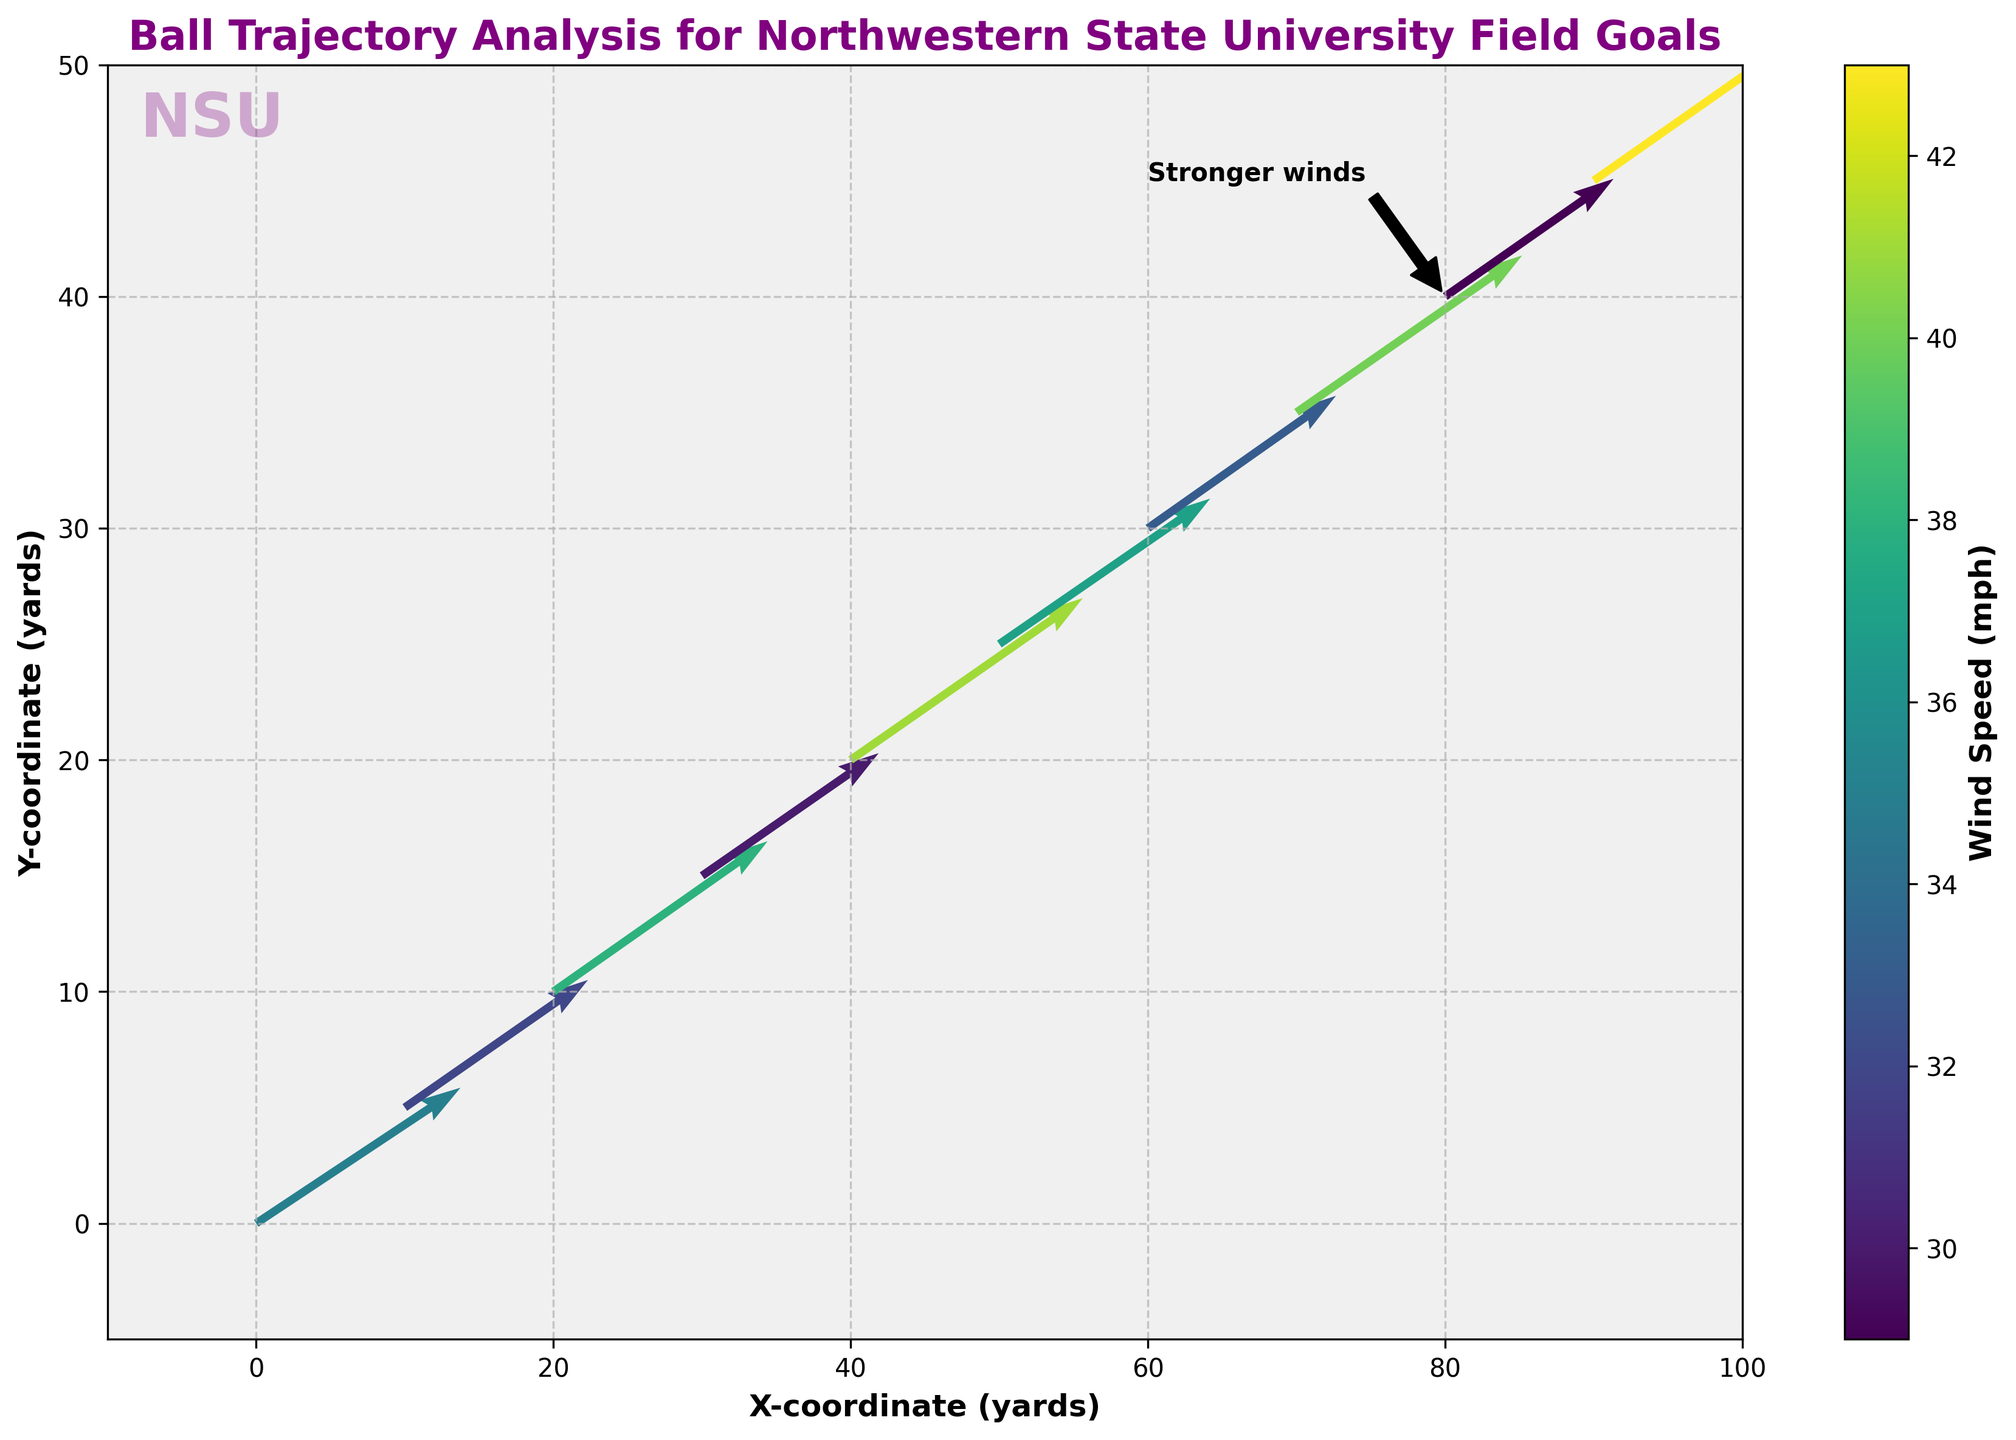What is the title of the figure? The title of the figure is displayed at the top and main text indicates what the plot is about.
Answer: Ball Trajectory Analysis for Northwestern State University Field Goals What does the color bar represent in this figure? The label on the color bar indicates what measure it represents, typically found on the vertical color gradient.
Answer: Wind Speed (mph) How many data points are depicted in the plot? Each arrow in the quiver plot represents a data point, and counting them gives the total number.
Answer: 10 What are the units for the X and Y coordinates in this plot? The axis labels provide information about the units for both X and Y coordinates.
Answer: Yards Which data point shows the strongest wind speed? The color intensity and the added annotation point to the data point with the strongest wind speed.
Answer: Point at (90, 45) Among the data points (30, 15) and (40, 20), which one experiences a higher wind speed? Comparing the colors of both arrows and checking which one is in a darker shade according to the color bar shows which wind speed is higher.
Answer: Point at (40, 20) What direction does the wind blow at the data point (0, 0)? The direction is indicated by the orientation of the arrow at (0, 0).
Answer: Northeast (or approximately) Compare the magnitudes of the wind speed for points located at (20, 10) and (70, 35). Which one is greater? By comparing the colors on the arrows and referencing the color bar, the intensity level can be determined.
Answer: Wind speed at (20, 10) > (70, 35) What is the average X-coordinate of the data points? Summing up all X-coordinates and dividing by the total number of points: (0 + 10 + 20 + 30 + 40 + 50 + 60 + 70 + 80 + 90) / 10
Answer: 45 How does the arrow length help in understanding the wind effect on the ball trajectory in this plot? Arrow length directly shows wind speed's magnitude and direction, aiding in visualizing how significantly and in which direction the wind influences the ball's path.
Answer: Indicates wind effect magnitude and direction 